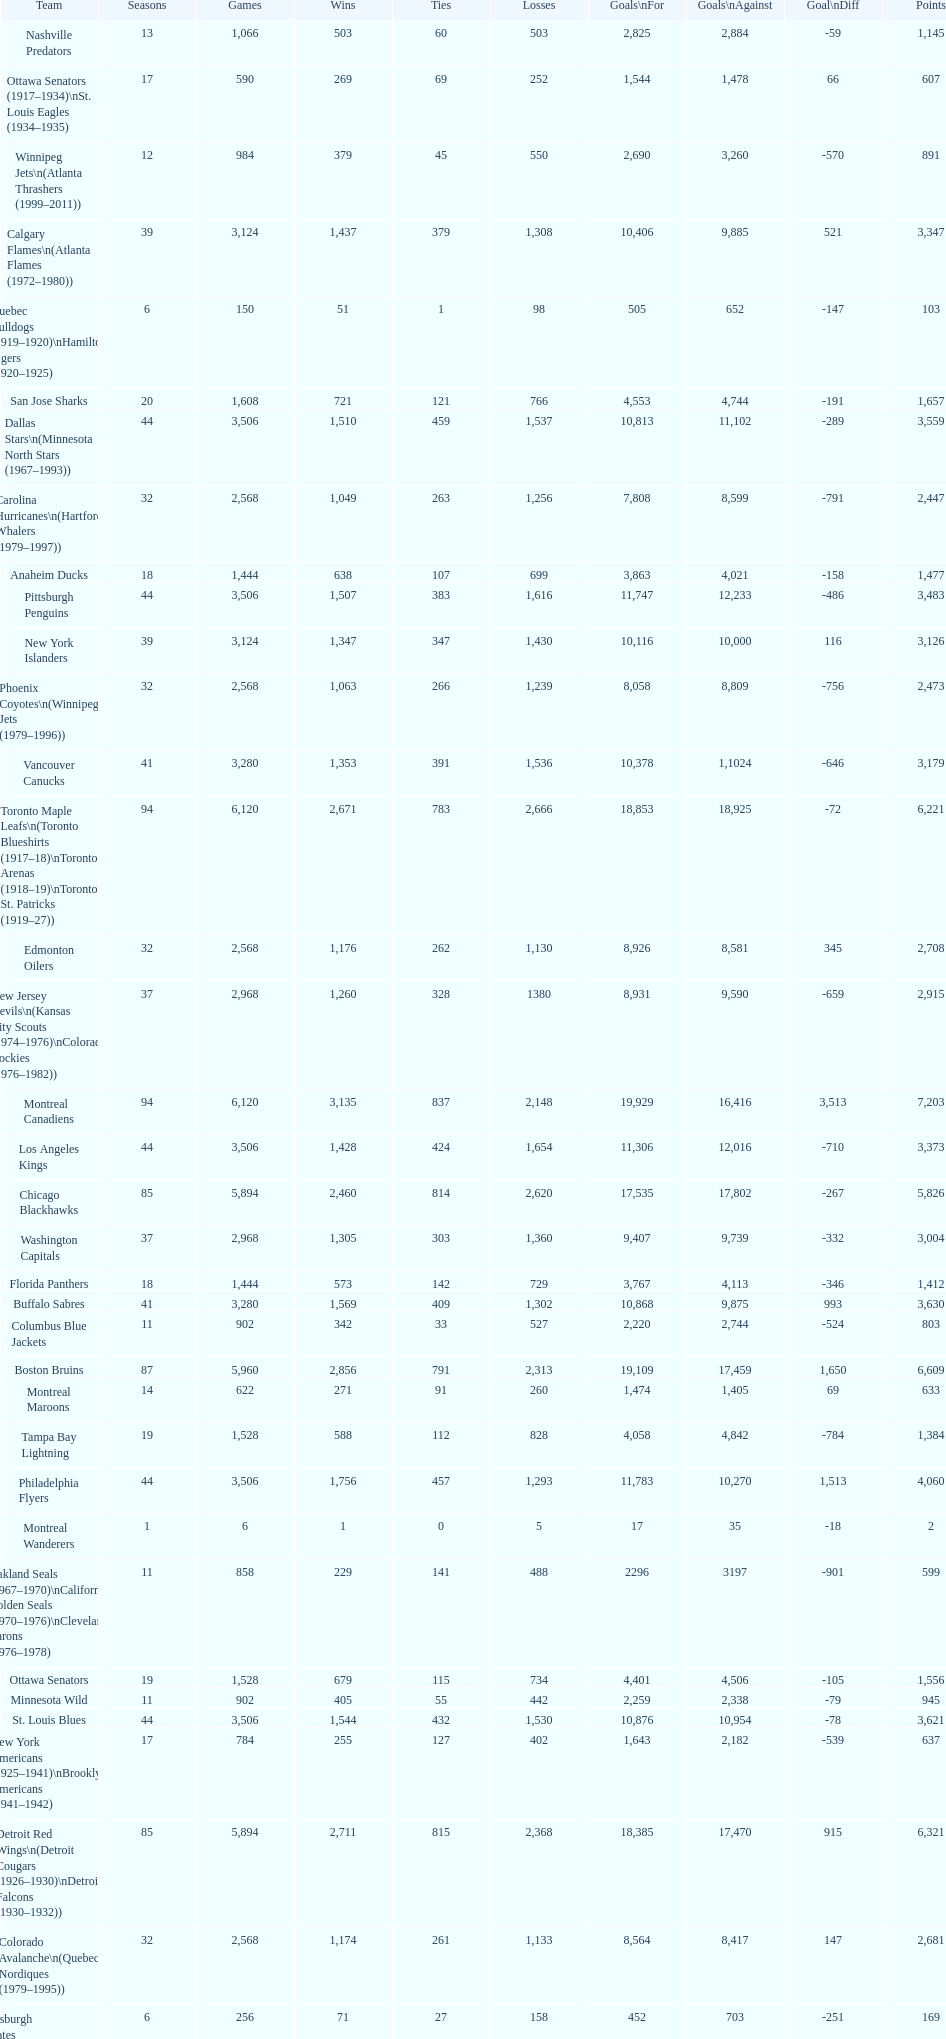Who has the least amount of losses? Montreal Wanderers. 